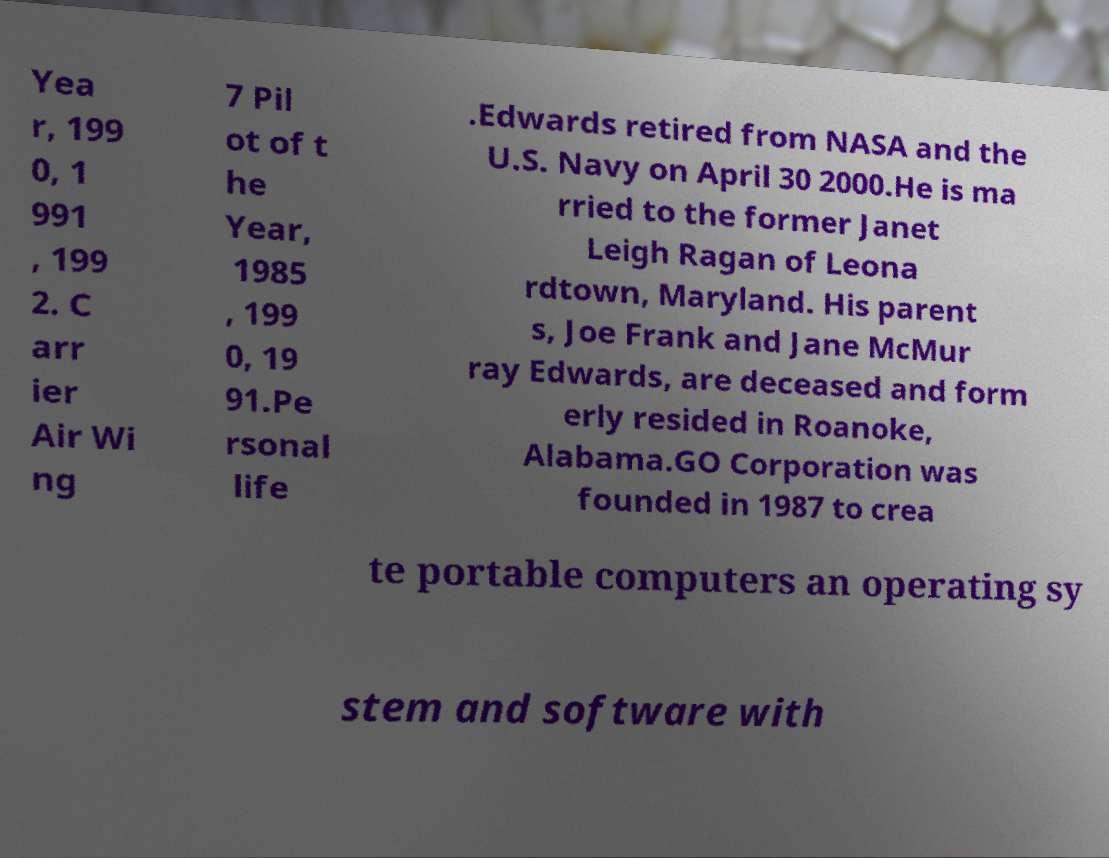Can you read and provide the text displayed in the image?This photo seems to have some interesting text. Can you extract and type it out for me? Yea r, 199 0, 1 991 , 199 2. C arr ier Air Wi ng 7 Pil ot of t he Year, 1985 , 199 0, 19 91.Pe rsonal life .Edwards retired from NASA and the U.S. Navy on April 30 2000.He is ma rried to the former Janet Leigh Ragan of Leona rdtown, Maryland. His parent s, Joe Frank and Jane McMur ray Edwards, are deceased and form erly resided in Roanoke, Alabama.GO Corporation was founded in 1987 to crea te portable computers an operating sy stem and software with 